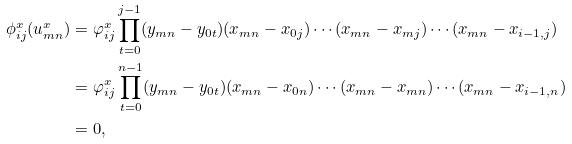Convert formula to latex. <formula><loc_0><loc_0><loc_500><loc_500>\phi _ { i j } ^ { x } ( u _ { m n } ^ { x } ) & = \varphi _ { i j } ^ { x } \prod _ { t = 0 } ^ { j - 1 } ( y _ { m n } - y _ { 0 t } ) ( x _ { m n } - x _ { 0 j } ) \cdots ( x _ { m n } - x _ { m j } ) \cdots ( x _ { m n } - x _ { i - 1 , j } ) \\ & = \varphi _ { i j } ^ { x } \prod _ { t = 0 } ^ { n - 1 } ( y _ { m n } - y _ { 0 t } ) ( x _ { m n } - x _ { 0 n } ) \cdots ( x _ { m n } - x _ { m n } ) \cdots ( x _ { m n } - x _ { i - 1 , n } ) \\ & = 0 ,</formula> 